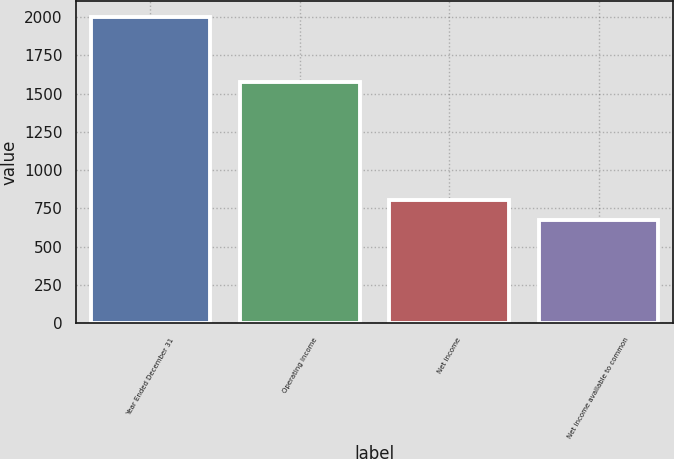Convert chart. <chart><loc_0><loc_0><loc_500><loc_500><bar_chart><fcel>Year Ended December 31<fcel>Operating income<fcel>Net income<fcel>Net income available to common<nl><fcel>2003<fcel>1577<fcel>806.9<fcel>674<nl></chart> 